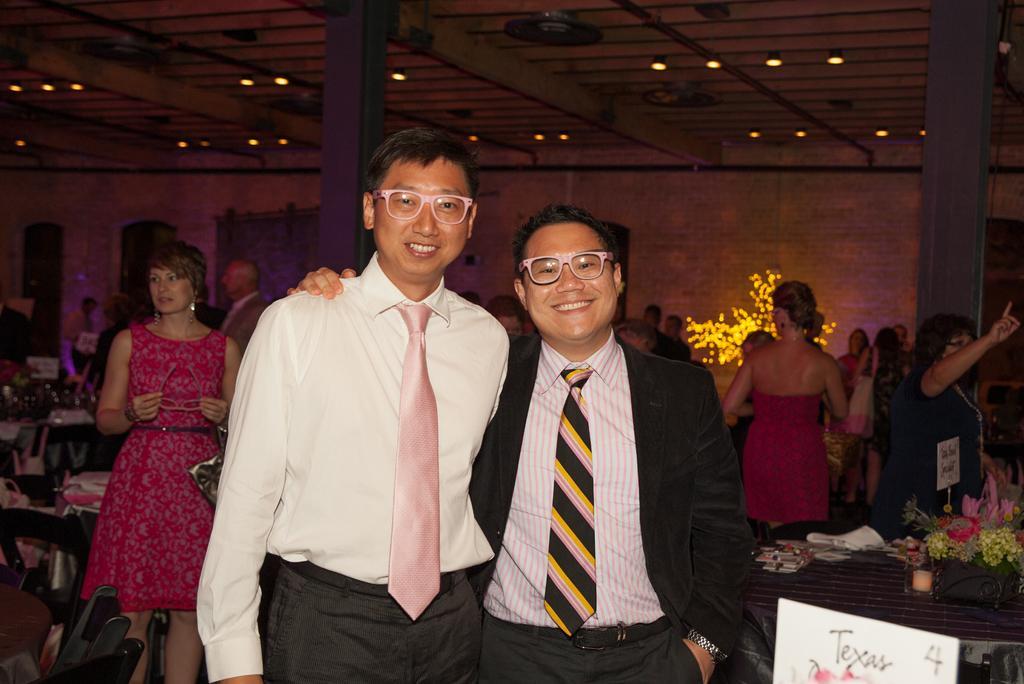How would you summarize this image in a sentence or two? In this image I can see the group of people with different color dresses. To the side of these people I can see the tables and chairs. On the tables I can see the flower vase, board and many objects. In the background I can see few more people and the lights in the top. 